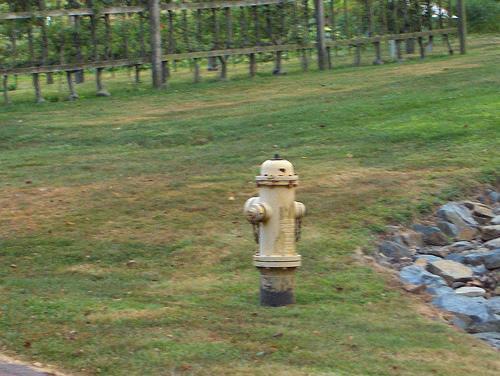How many fire hydrants are in this picture?
Give a very brief answer. 1. 